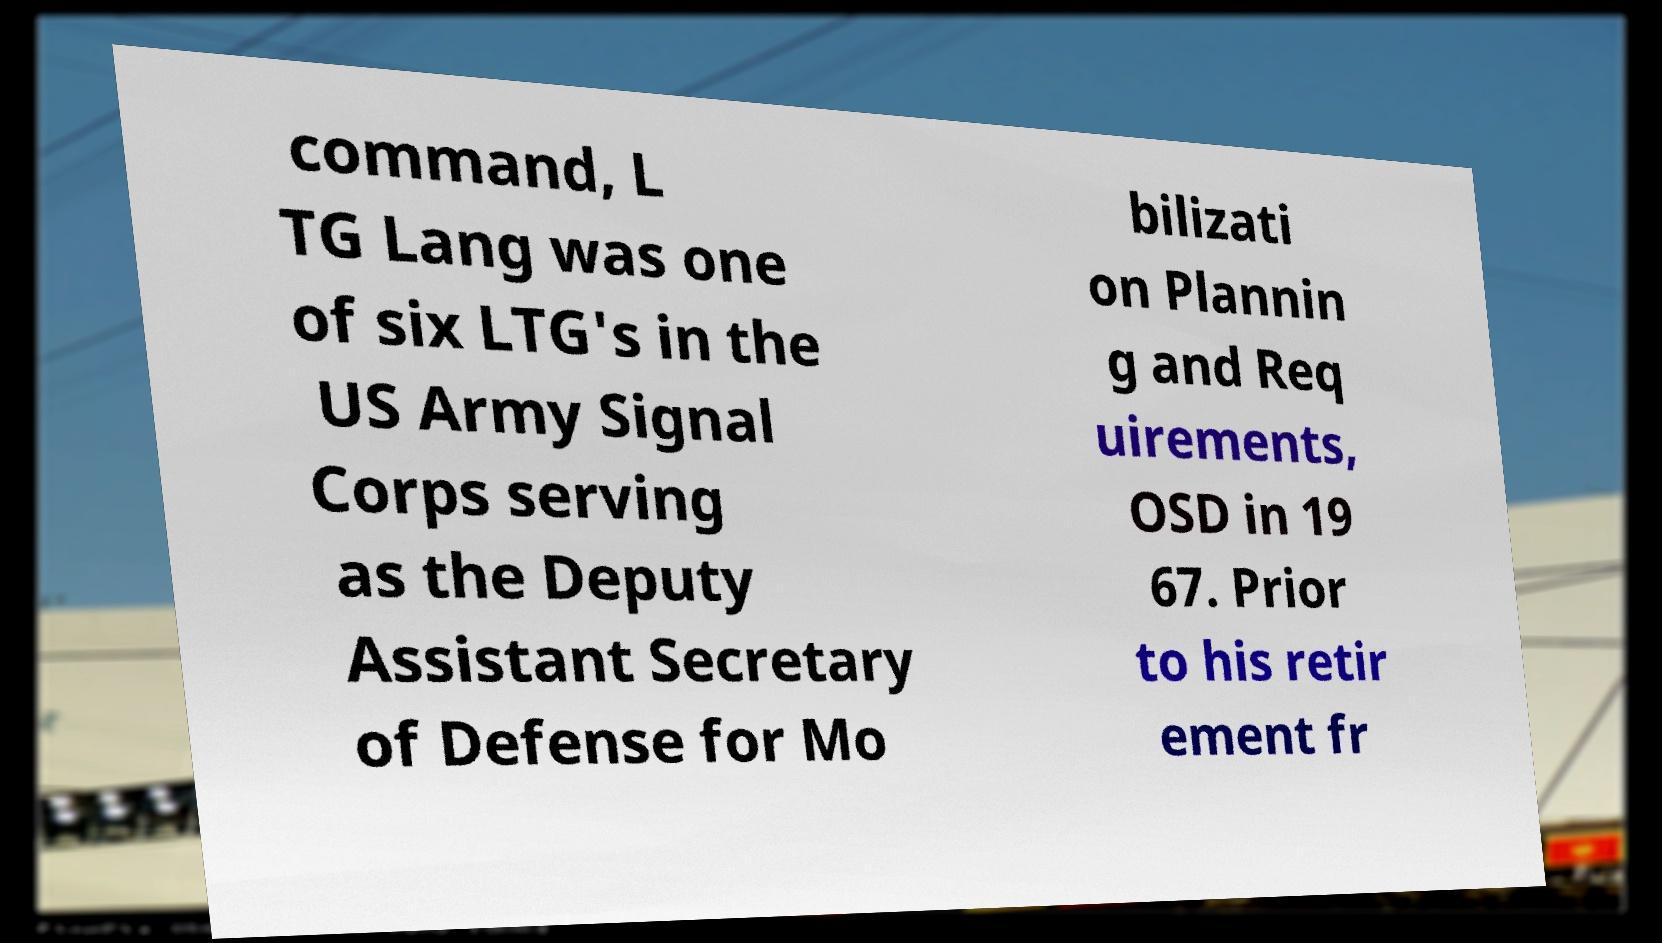Could you extract and type out the text from this image? command, L TG Lang was one of six LTG's in the US Army Signal Corps serving as the Deputy Assistant Secretary of Defense for Mo bilizati on Plannin g and Req uirements, OSD in 19 67. Prior to his retir ement fr 